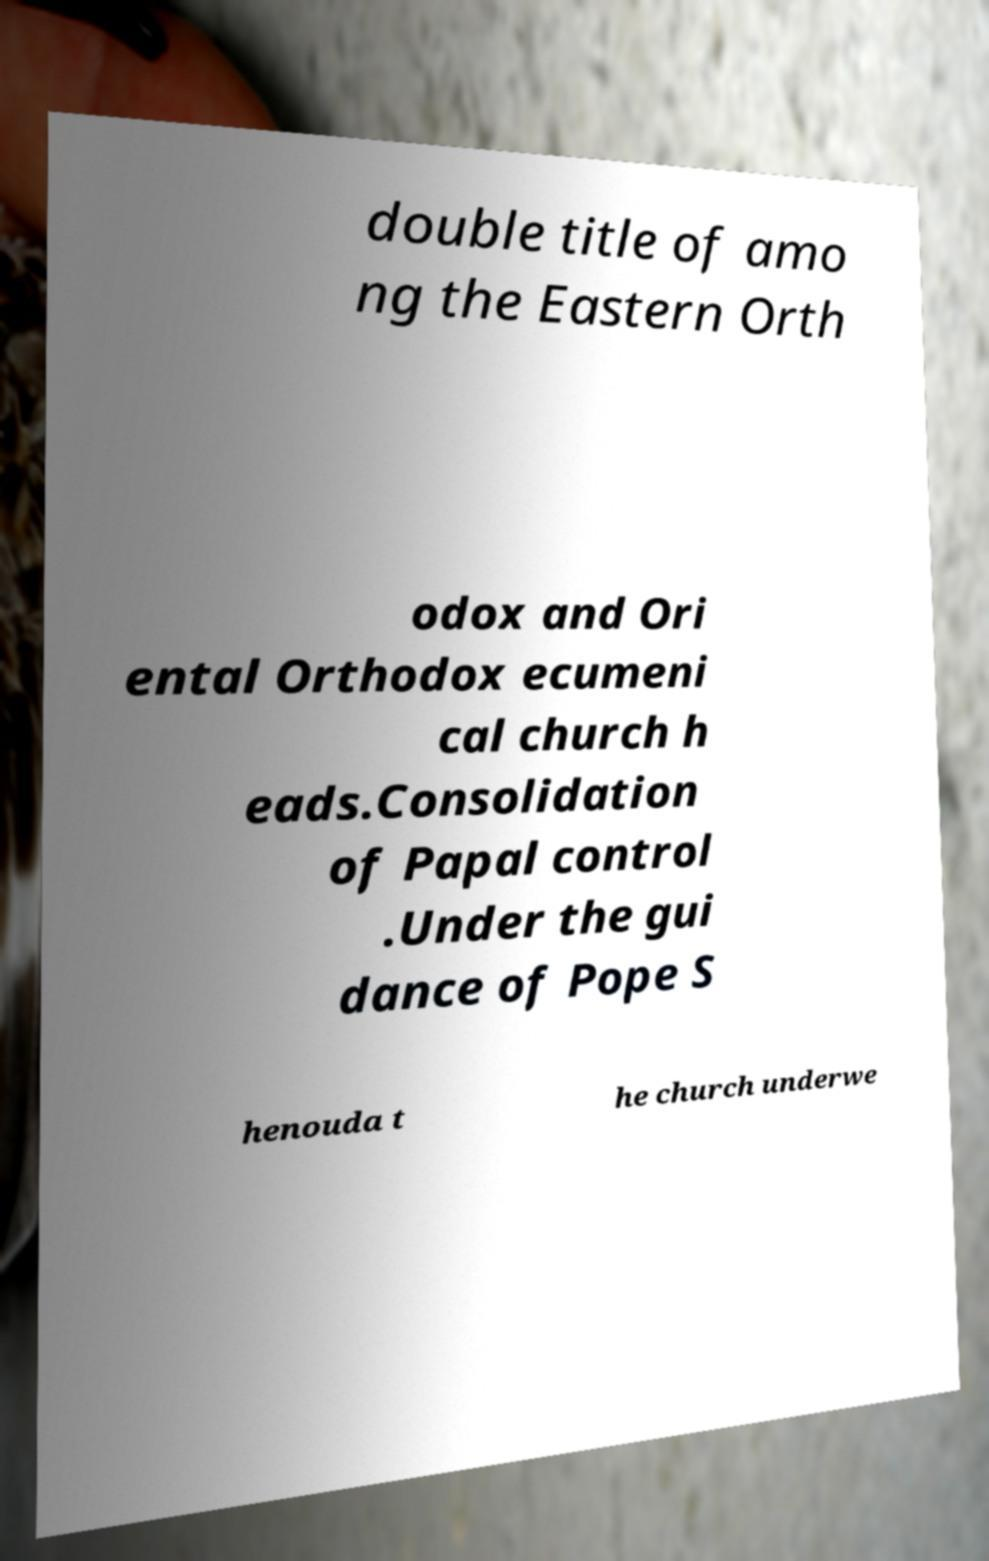Could you assist in decoding the text presented in this image and type it out clearly? double title of amo ng the Eastern Orth odox and Ori ental Orthodox ecumeni cal church h eads.Consolidation of Papal control .Under the gui dance of Pope S henouda t he church underwe 